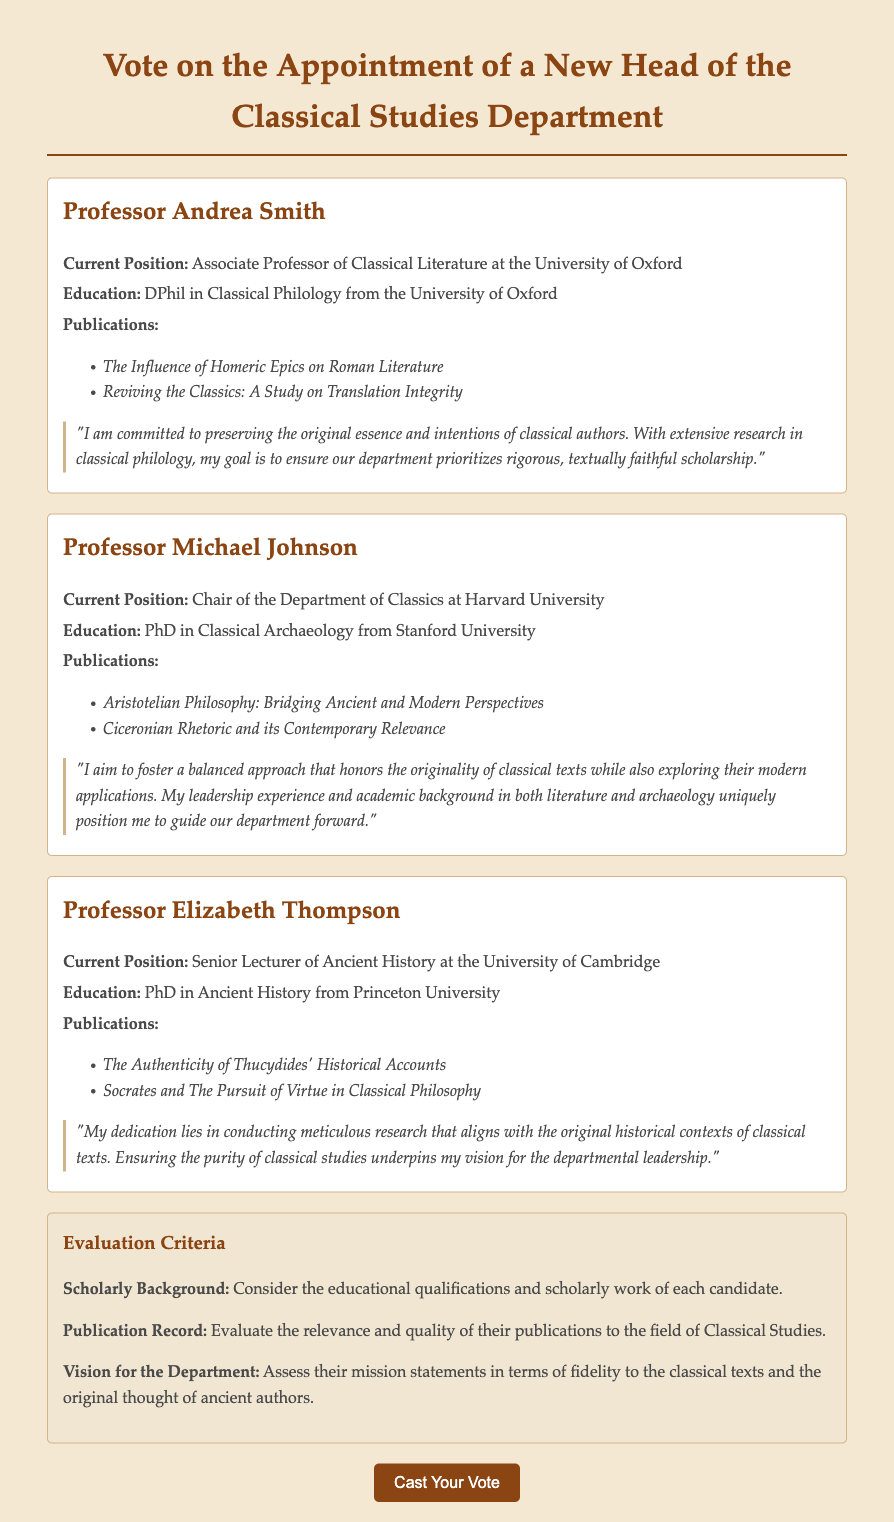What is the current position of Professor Andrea Smith? The current position is explicitly stated in the document as "Associate Professor of Classical Literature at the University of Oxford."
Answer: Associate Professor of Classical Literature at the University of Oxford What are the titles of the publications by Professor Michael Johnson? The titles of the publications are listed in a bullet format under his section.
Answer: Aristotelian Philosophy: Bridging Ancient and Modern Perspectives, Ciceronian Rhetoric and its Contemporary Relevance What is the highest degree attained by Professor Elizabeth Thompson? Her highest degree is mentioned as "PhD in Ancient History from Princeton University."
Answer: PhD in Ancient History Which candidate is committed to preserving the original essence of classical authors? The document states that this commitment is highlighted in Professor Andrea Smith's statement.
Answer: Professor Andrea Smith How many candidates have a PhD? The document provides educational qualifications for each candidate, and all three are listed as having a PhD.
Answer: Three What is one of the evaluation criteria listed in the document? The evaluation criteria includes several aspects, one of which is "Scholarly Background."
Answer: Scholarly Background Who aims to foster a balanced approach between classical texts and modern applications? This objective is clearly mentioned in Professor Michael Johnson's statement.
Answer: Professor Michael Johnson What university is Professor Elizabeth Thompson associated with? The association is indicated in her designation as "Senior Lecturer of Ancient History at the University of Cambridge."
Answer: University of Cambridge What is the background of Professor Michael Johnson in terms of education? The document specifies that he holds a PhD in Classical Archaeology from Stanford University.
Answer: PhD in Classical Archaeology 